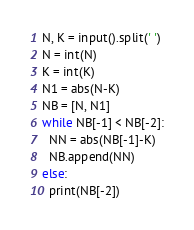<code> <loc_0><loc_0><loc_500><loc_500><_Python_>N, K = input().split(' ')
N = int(N)
K = int(K)
N1 = abs(N-K)
NB = [N, N1]
while NB[-1] < NB[-2]:
  NN = abs(NB[-1]-K)
  NB.append(NN)
else:
  print(NB[-2])</code> 